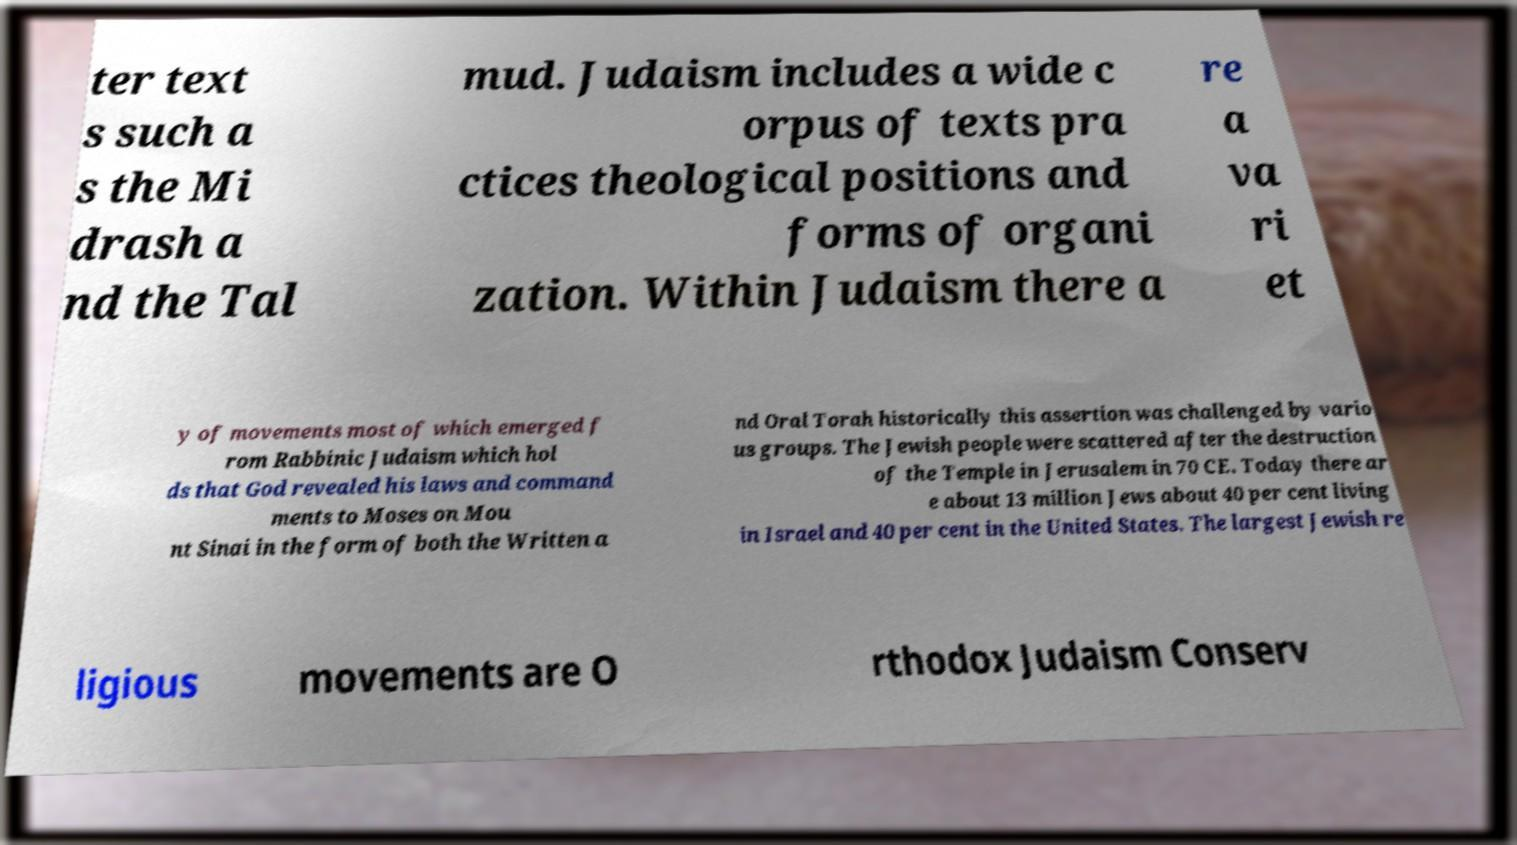Could you extract and type out the text from this image? ter text s such a s the Mi drash a nd the Tal mud. Judaism includes a wide c orpus of texts pra ctices theological positions and forms of organi zation. Within Judaism there a re a va ri et y of movements most of which emerged f rom Rabbinic Judaism which hol ds that God revealed his laws and command ments to Moses on Mou nt Sinai in the form of both the Written a nd Oral Torah historically this assertion was challenged by vario us groups. The Jewish people were scattered after the destruction of the Temple in Jerusalem in 70 CE. Today there ar e about 13 million Jews about 40 per cent living in Israel and 40 per cent in the United States. The largest Jewish re ligious movements are O rthodox Judaism Conserv 